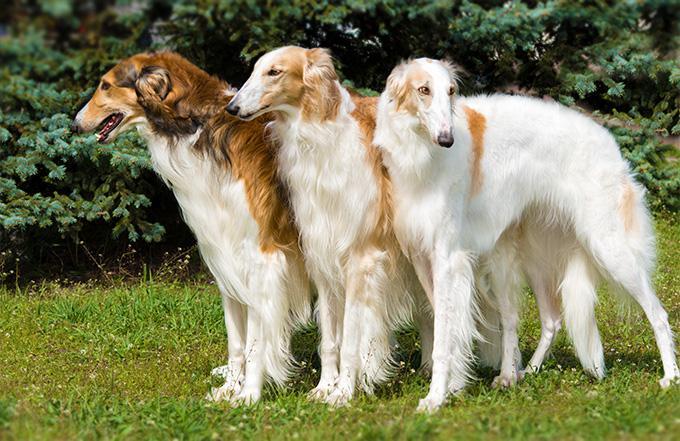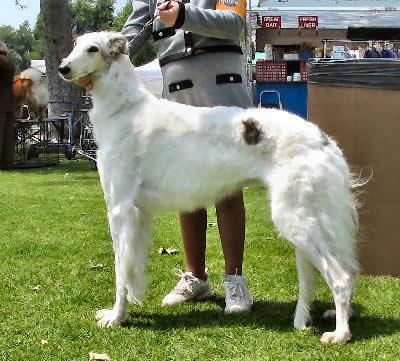The first image is the image on the left, the second image is the image on the right. For the images shown, is this caption "There are no more than 2 dogs per image pair" true? Answer yes or no. No. The first image is the image on the left, the second image is the image on the right. Assess this claim about the two images: "There is a dog in the center of both images.". Correct or not? Answer yes or no. Yes. 